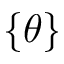Convert formula to latex. <formula><loc_0><loc_0><loc_500><loc_500>\{ \theta \}</formula> 